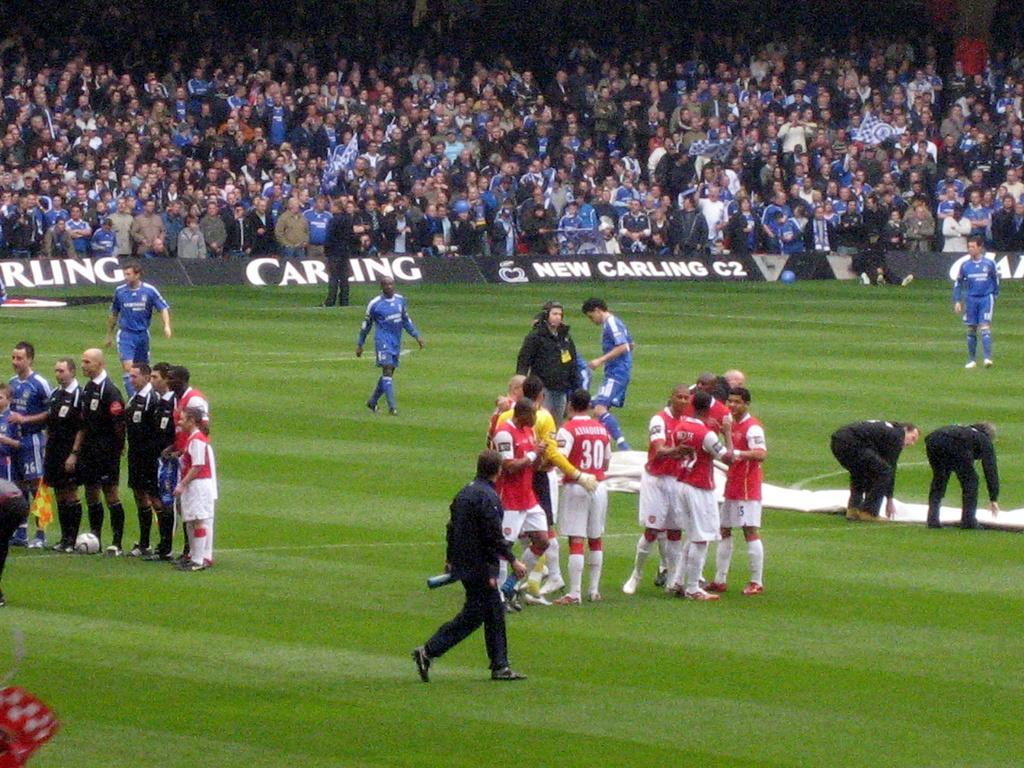In one or two sentences, can you explain what this image depicts? Here we can see few persons on the ground and there are hoardings. In the background we can see crowd. 